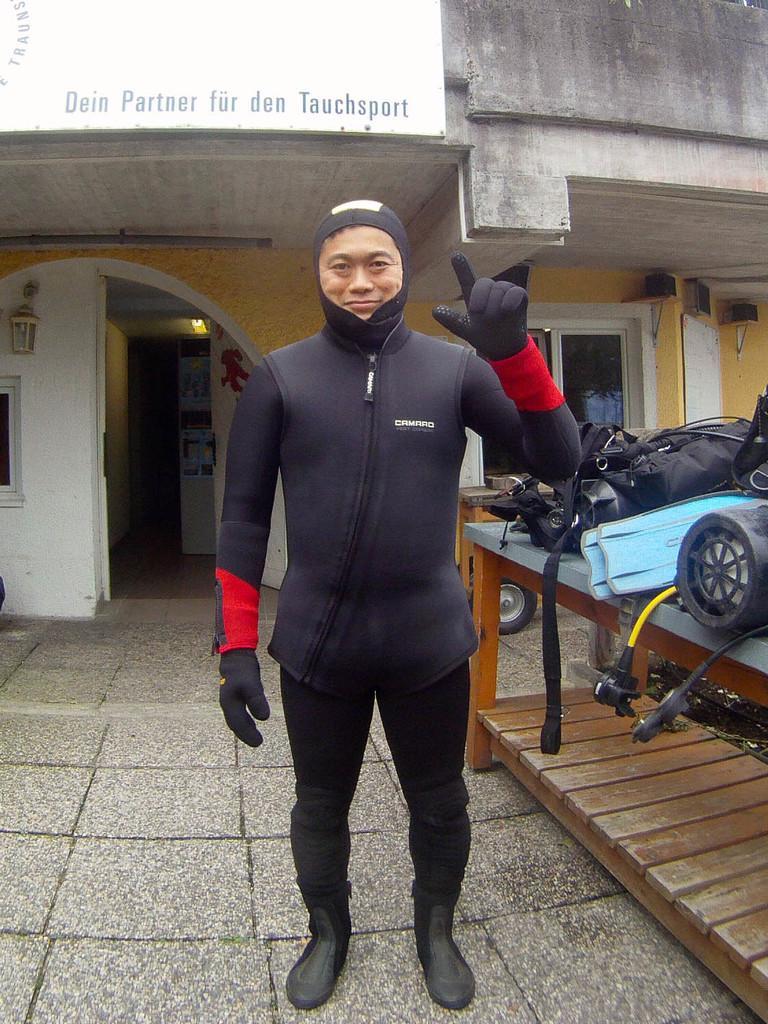How would you summarize this image in a sentence or two? In this image in the center there is a person standing and smiling. On the right side there are objects on the table which are black and blue in colour. In the background there is a building and on the wall of the building there is a board with some text written on it, there is a window and there are objects which are black in colour on the wall, there are lights and there is a wheel which is visible in front of the building. 